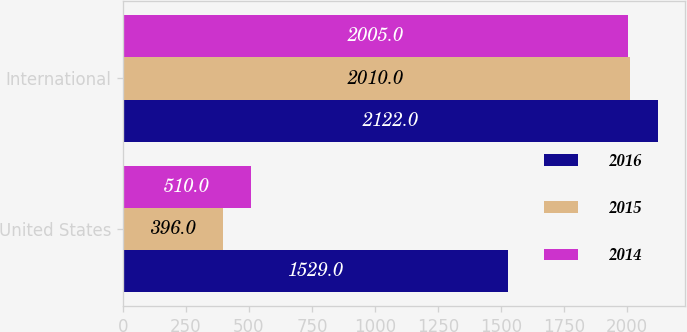Convert chart to OTSL. <chart><loc_0><loc_0><loc_500><loc_500><stacked_bar_chart><ecel><fcel>United States<fcel>International<nl><fcel>2016<fcel>1529<fcel>2122<nl><fcel>2015<fcel>396<fcel>2010<nl><fcel>2014<fcel>510<fcel>2005<nl></chart> 